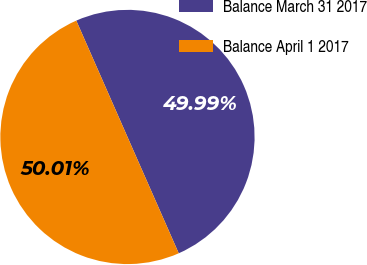Convert chart to OTSL. <chart><loc_0><loc_0><loc_500><loc_500><pie_chart><fcel>Balance March 31 2017<fcel>Balance April 1 2017<nl><fcel>49.99%<fcel>50.01%<nl></chart> 